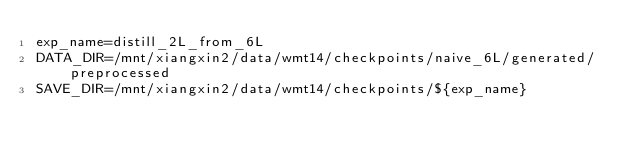Convert code to text. <code><loc_0><loc_0><loc_500><loc_500><_Bash_>exp_name=distill_2L_from_6L
DATA_DIR=/mnt/xiangxin2/data/wmt14/checkpoints/naive_6L/generated/preprocessed
SAVE_DIR=/mnt/xiangxin2/data/wmt14/checkpoints/${exp_name}
</code> 